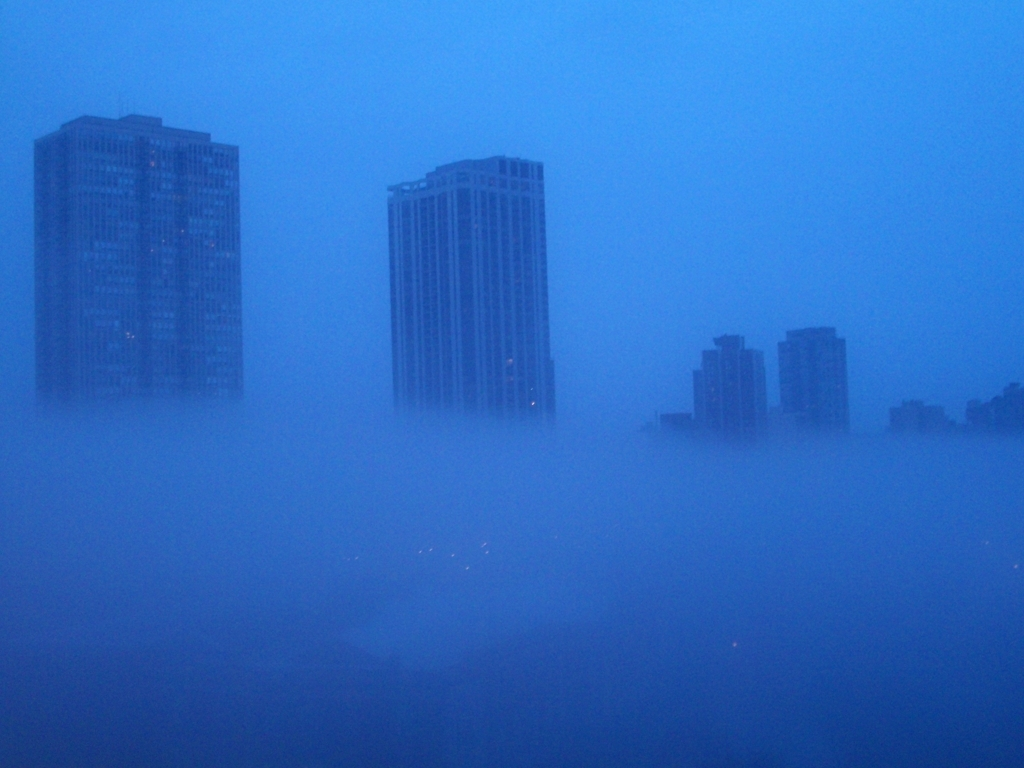What is the quality of this image?
A. Poor
B. Outstanding
C. Superb
D. Excellent
Answer with the option's letter from the given choices directly. The quality of the image can be considered 'A. Poor' due to the excessive haze which obscures the details of the buildings, leading to a significant reduction in the sharpness and clarity that would typically constitute a high-quality photograph. 